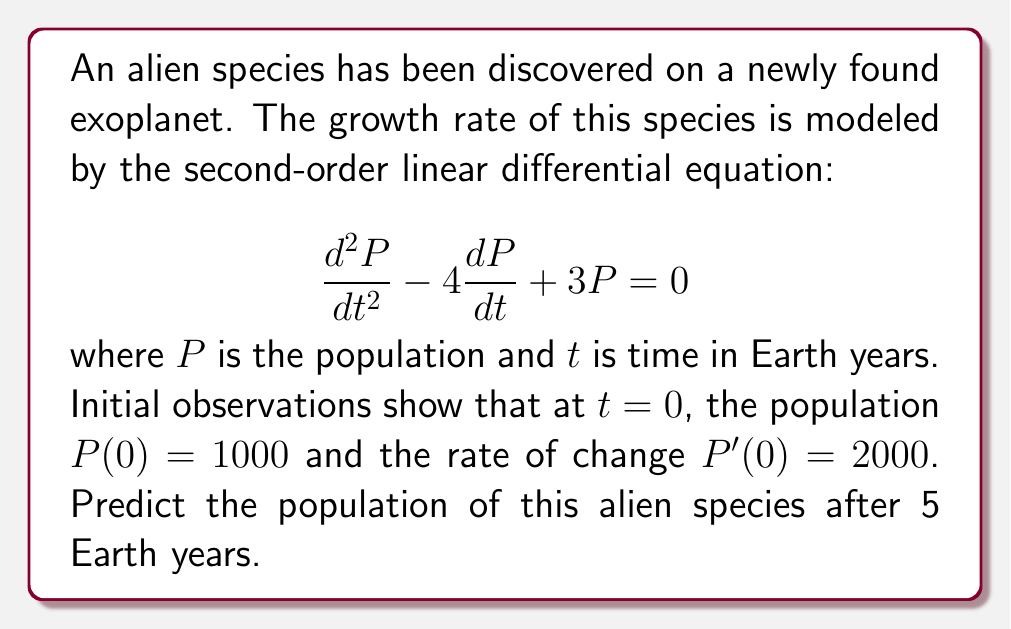Solve this math problem. To solve this problem, we need to follow these steps:

1) The general solution for this second-order linear differential equation is:

   $$P(t) = c_1e^{r_1t} + c_2e^{r_2t}$$

   where $r_1$ and $r_2$ are the roots of the characteristic equation.

2) The characteristic equation is:

   $$r^2 - 4r + 3 = 0$$

3) Solving this equation:

   $$(r-3)(r-1) = 0$$
   
   So, $r_1 = 3$ and $r_2 = 1$

4) Therefore, the general solution is:

   $$P(t) = c_1e^{3t} + c_2e^t$$

5) To find $c_1$ and $c_2$, we use the initial conditions:

   $P(0) = 1000$: $c_1 + c_2 = 1000$
   $P'(0) = 2000$: $3c_1 + c_2 = 2000$

6) Solving these equations:

   $c_2 = 1000 - c_1$
   $3c_1 + (1000 - c_1) = 2000$
   $2c_1 = 1000$
   $c_1 = 500$
   $c_2 = 500$

7) The particular solution is:

   $$P(t) = 500e^{3t} + 500e^t$$

8) To find the population after 5 years, we calculate $P(5)$:

   $$P(5) = 500e^{3(5)} + 500e^5$$
   $$P(5) = 500e^{15} + 500e^5$$

9) Using a calculator:

   $$P(5) \approx 1,631,506,830$$
Answer: The predicted population of the alien species after 5 Earth years is approximately 1,631,506,830. 